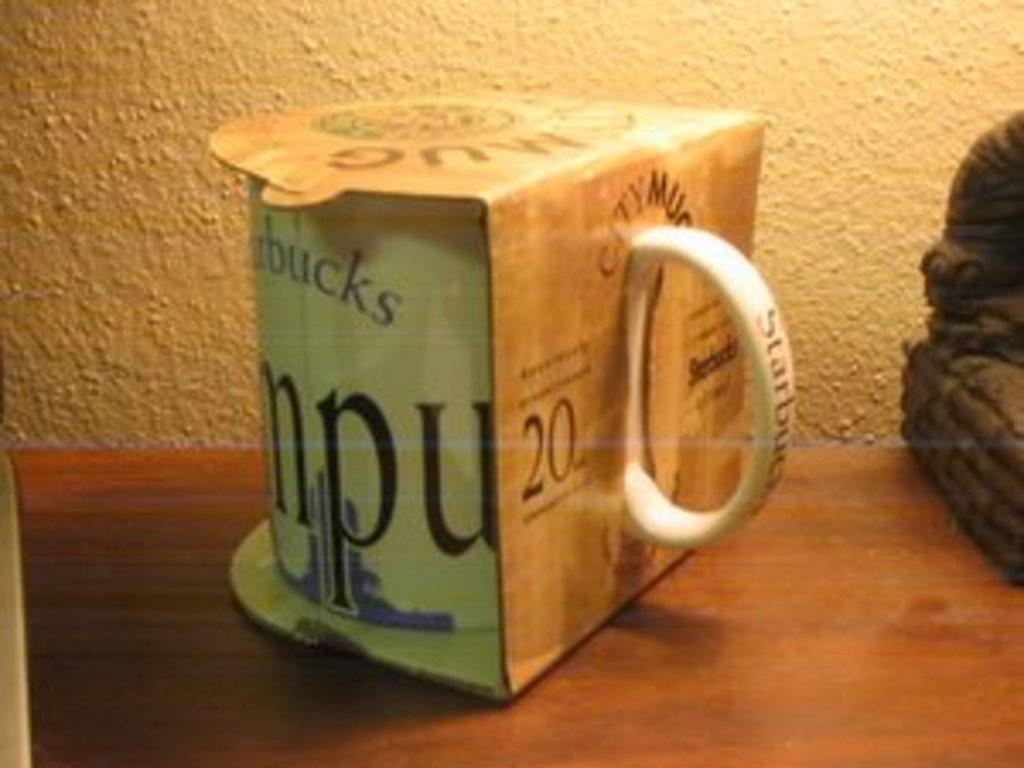<image>
Describe the image concisely. White Starbucks cup still inside it's cover and unopened. 